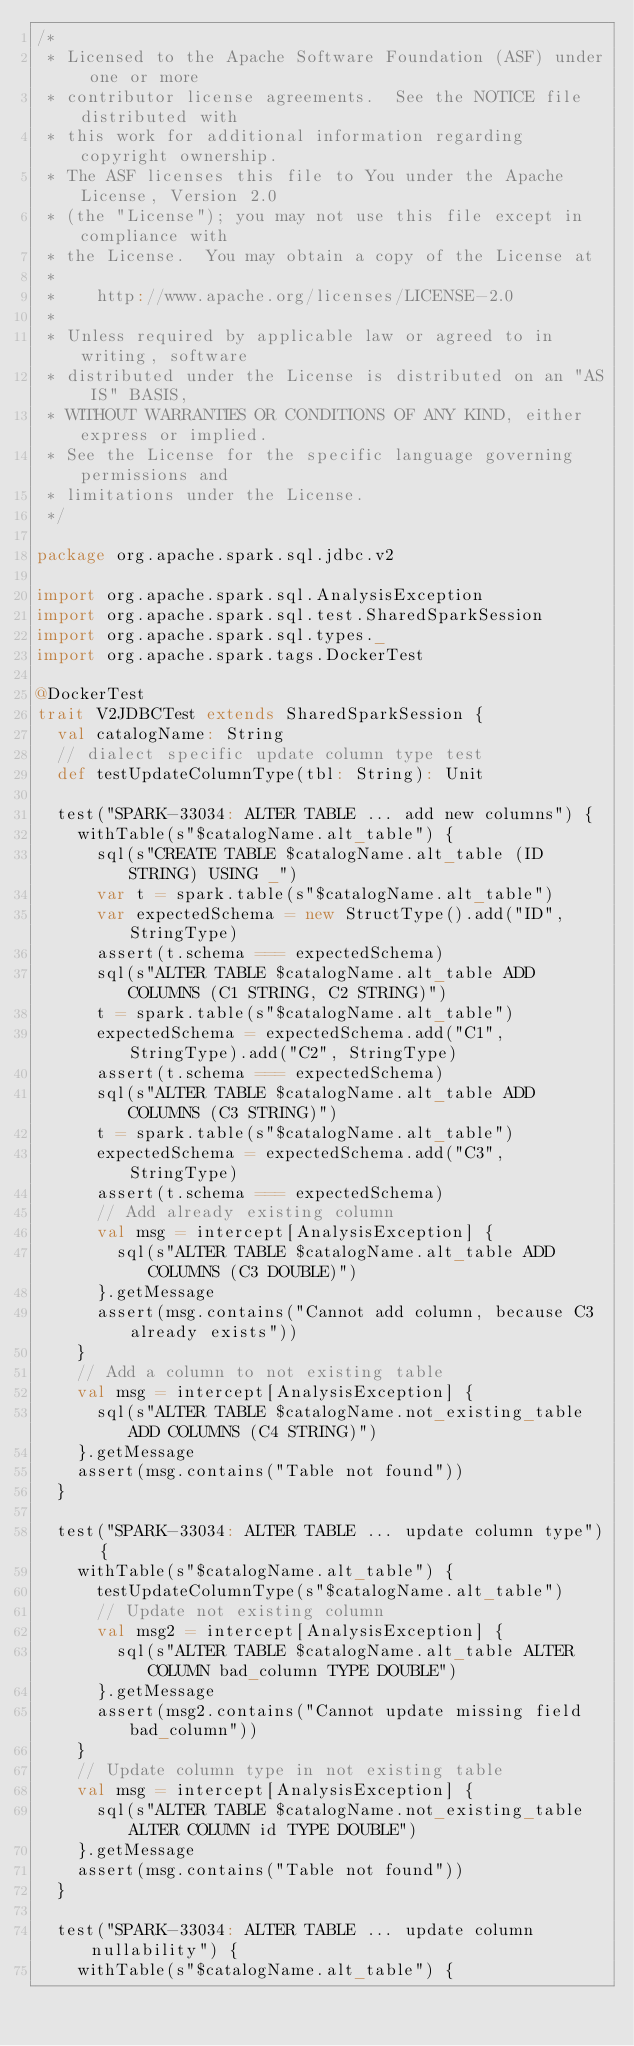Convert code to text. <code><loc_0><loc_0><loc_500><loc_500><_Scala_>/*
 * Licensed to the Apache Software Foundation (ASF) under one or more
 * contributor license agreements.  See the NOTICE file distributed with
 * this work for additional information regarding copyright ownership.
 * The ASF licenses this file to You under the Apache License, Version 2.0
 * (the "License"); you may not use this file except in compliance with
 * the License.  You may obtain a copy of the License at
 *
 *    http://www.apache.org/licenses/LICENSE-2.0
 *
 * Unless required by applicable law or agreed to in writing, software
 * distributed under the License is distributed on an "AS IS" BASIS,
 * WITHOUT WARRANTIES OR CONDITIONS OF ANY KIND, either express or implied.
 * See the License for the specific language governing permissions and
 * limitations under the License.
 */

package org.apache.spark.sql.jdbc.v2

import org.apache.spark.sql.AnalysisException
import org.apache.spark.sql.test.SharedSparkSession
import org.apache.spark.sql.types._
import org.apache.spark.tags.DockerTest

@DockerTest
trait V2JDBCTest extends SharedSparkSession {
  val catalogName: String
  // dialect specific update column type test
  def testUpdateColumnType(tbl: String): Unit

  test("SPARK-33034: ALTER TABLE ... add new columns") {
    withTable(s"$catalogName.alt_table") {
      sql(s"CREATE TABLE $catalogName.alt_table (ID STRING) USING _")
      var t = spark.table(s"$catalogName.alt_table")
      var expectedSchema = new StructType().add("ID", StringType)
      assert(t.schema === expectedSchema)
      sql(s"ALTER TABLE $catalogName.alt_table ADD COLUMNS (C1 STRING, C2 STRING)")
      t = spark.table(s"$catalogName.alt_table")
      expectedSchema = expectedSchema.add("C1", StringType).add("C2", StringType)
      assert(t.schema === expectedSchema)
      sql(s"ALTER TABLE $catalogName.alt_table ADD COLUMNS (C3 STRING)")
      t = spark.table(s"$catalogName.alt_table")
      expectedSchema = expectedSchema.add("C3", StringType)
      assert(t.schema === expectedSchema)
      // Add already existing column
      val msg = intercept[AnalysisException] {
        sql(s"ALTER TABLE $catalogName.alt_table ADD COLUMNS (C3 DOUBLE)")
      }.getMessage
      assert(msg.contains("Cannot add column, because C3 already exists"))
    }
    // Add a column to not existing table
    val msg = intercept[AnalysisException] {
      sql(s"ALTER TABLE $catalogName.not_existing_table ADD COLUMNS (C4 STRING)")
    }.getMessage
    assert(msg.contains("Table not found"))
  }

  test("SPARK-33034: ALTER TABLE ... update column type") {
    withTable(s"$catalogName.alt_table") {
      testUpdateColumnType(s"$catalogName.alt_table")
      // Update not existing column
      val msg2 = intercept[AnalysisException] {
        sql(s"ALTER TABLE $catalogName.alt_table ALTER COLUMN bad_column TYPE DOUBLE")
      }.getMessage
      assert(msg2.contains("Cannot update missing field bad_column"))
    }
    // Update column type in not existing table
    val msg = intercept[AnalysisException] {
      sql(s"ALTER TABLE $catalogName.not_existing_table ALTER COLUMN id TYPE DOUBLE")
    }.getMessage
    assert(msg.contains("Table not found"))
  }

  test("SPARK-33034: ALTER TABLE ... update column nullability") {
    withTable(s"$catalogName.alt_table") {</code> 